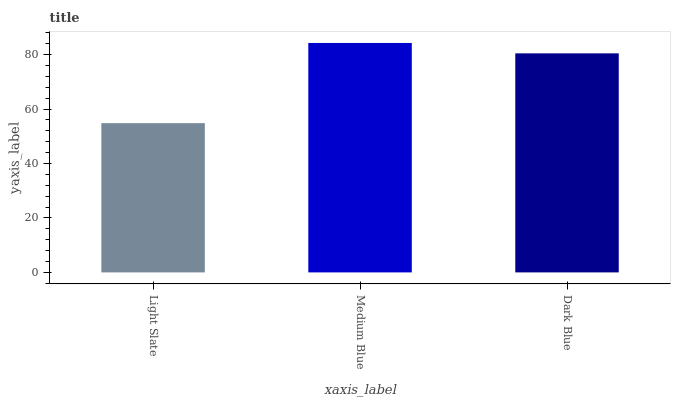Is Light Slate the minimum?
Answer yes or no. Yes. Is Medium Blue the maximum?
Answer yes or no. Yes. Is Dark Blue the minimum?
Answer yes or no. No. Is Dark Blue the maximum?
Answer yes or no. No. Is Medium Blue greater than Dark Blue?
Answer yes or no. Yes. Is Dark Blue less than Medium Blue?
Answer yes or no. Yes. Is Dark Blue greater than Medium Blue?
Answer yes or no. No. Is Medium Blue less than Dark Blue?
Answer yes or no. No. Is Dark Blue the high median?
Answer yes or no. Yes. Is Dark Blue the low median?
Answer yes or no. Yes. Is Light Slate the high median?
Answer yes or no. No. Is Light Slate the low median?
Answer yes or no. No. 